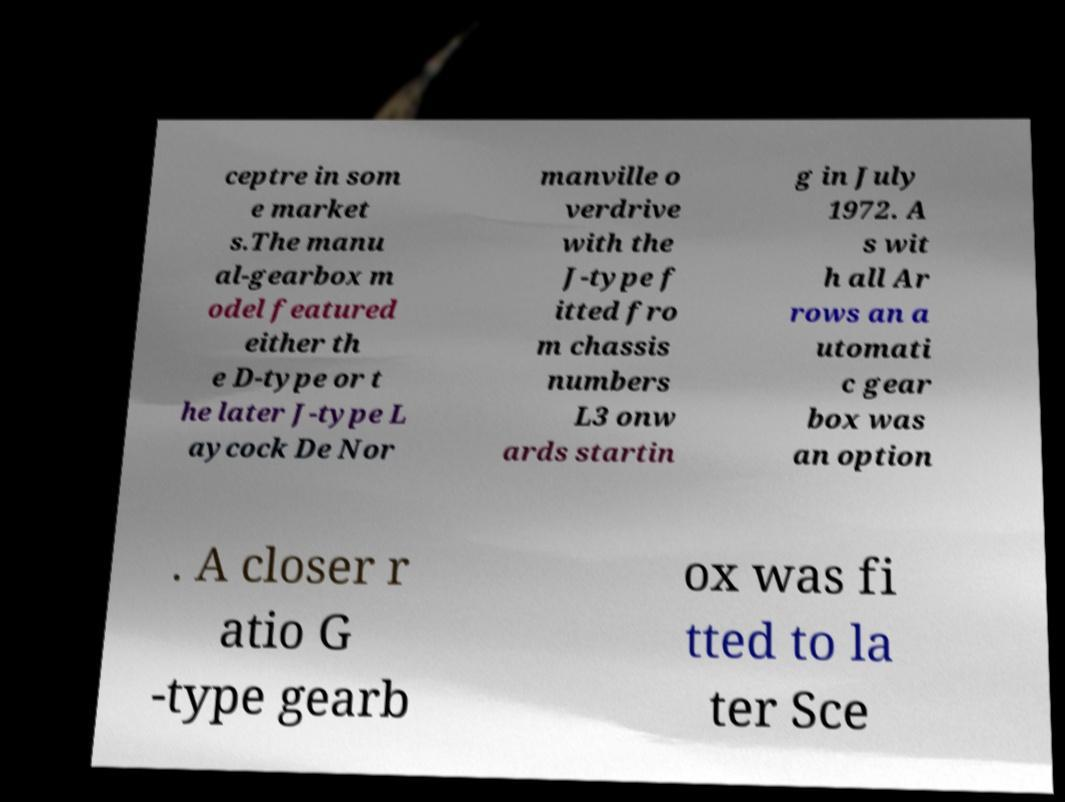What messages or text are displayed in this image? I need them in a readable, typed format. ceptre in som e market s.The manu al-gearbox m odel featured either th e D-type or t he later J-type L aycock De Nor manville o verdrive with the J-type f itted fro m chassis numbers L3 onw ards startin g in July 1972. A s wit h all Ar rows an a utomati c gear box was an option . A closer r atio G -type gearb ox was fi tted to la ter Sce 